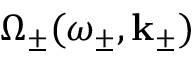Convert formula to latex. <formula><loc_0><loc_0><loc_500><loc_500>\Omega _ { \pm } ( \omega _ { \pm } , k _ { \pm } )</formula> 